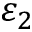<formula> <loc_0><loc_0><loc_500><loc_500>\varepsilon _ { 2 }</formula> 